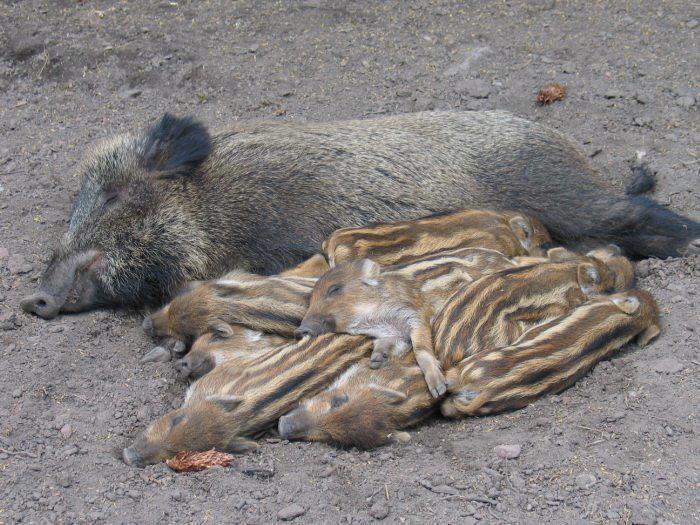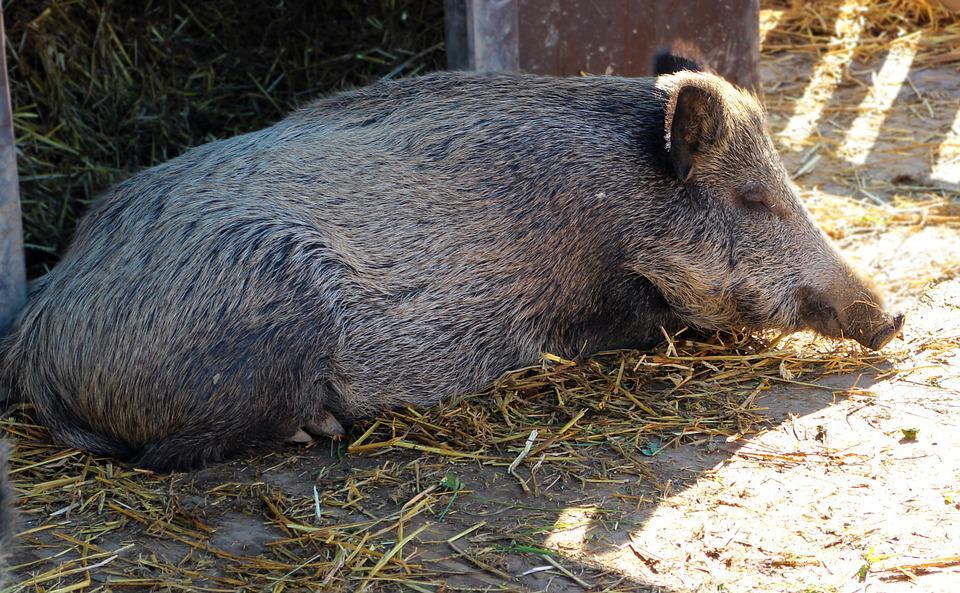The first image is the image on the left, the second image is the image on the right. Evaluate the accuracy of this statement regarding the images: "The left image contains exactly one boar.". Is it true? Answer yes or no. No. The first image is the image on the left, the second image is the image on the right. Given the left and right images, does the statement "An image shows at least two baby piglets with distinctive striped fur lying in front of an older wild pig that is lying on its side." hold true? Answer yes or no. Yes. 